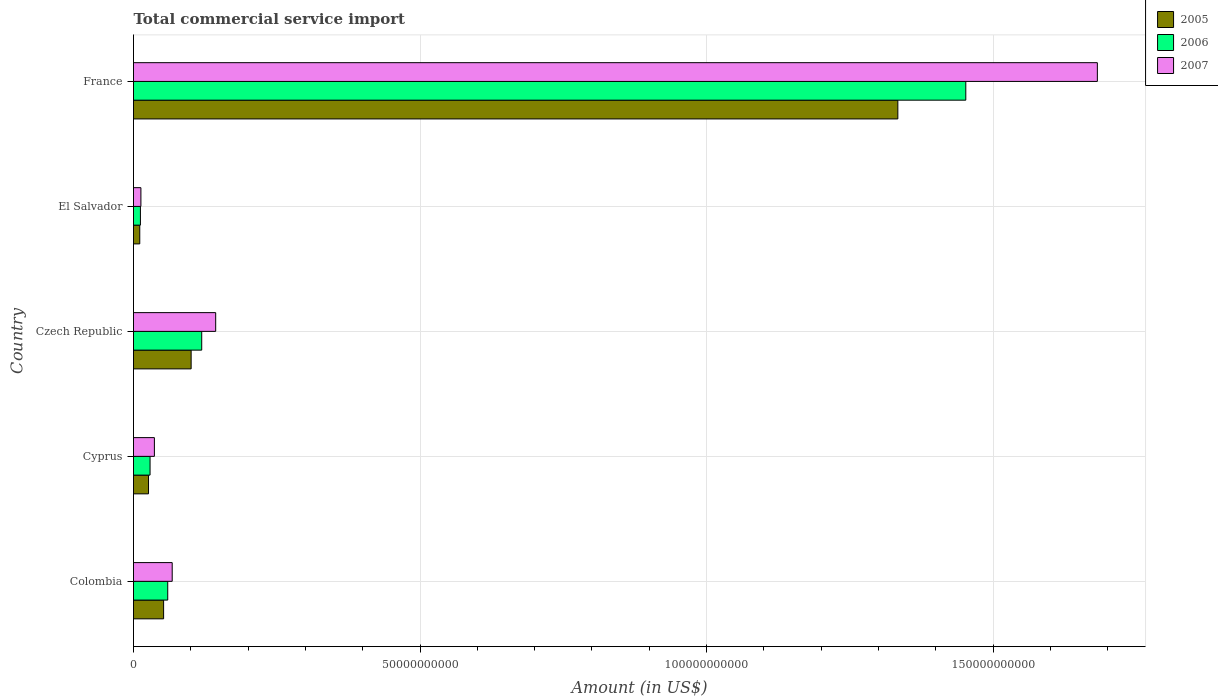How many groups of bars are there?
Keep it short and to the point. 5. Are the number of bars per tick equal to the number of legend labels?
Ensure brevity in your answer.  Yes. How many bars are there on the 2nd tick from the bottom?
Offer a terse response. 3. What is the total commercial service import in 2007 in Czech Republic?
Your answer should be compact. 1.43e+1. Across all countries, what is the maximum total commercial service import in 2005?
Keep it short and to the point. 1.33e+11. Across all countries, what is the minimum total commercial service import in 2005?
Give a very brief answer. 1.09e+09. In which country was the total commercial service import in 2007 maximum?
Your answer should be compact. France. In which country was the total commercial service import in 2006 minimum?
Ensure brevity in your answer.  El Salvador. What is the total total commercial service import in 2007 in the graph?
Your answer should be compact. 1.94e+11. What is the difference between the total commercial service import in 2005 in Colombia and that in Czech Republic?
Ensure brevity in your answer.  -4.80e+09. What is the difference between the total commercial service import in 2006 in Cyprus and the total commercial service import in 2005 in Colombia?
Ensure brevity in your answer.  -2.36e+09. What is the average total commercial service import in 2006 per country?
Keep it short and to the point. 3.34e+1. What is the difference between the total commercial service import in 2006 and total commercial service import in 2005 in Cyprus?
Your answer should be compact. 2.68e+08. In how many countries, is the total commercial service import in 2005 greater than 140000000000 US$?
Your response must be concise. 0. What is the ratio of the total commercial service import in 2007 in Colombia to that in Czech Republic?
Your response must be concise. 0.47. What is the difference between the highest and the second highest total commercial service import in 2005?
Keep it short and to the point. 1.23e+11. What is the difference between the highest and the lowest total commercial service import in 2006?
Provide a succinct answer. 1.44e+11. What does the 1st bar from the bottom in France represents?
Offer a very short reply. 2005. Are all the bars in the graph horizontal?
Your response must be concise. Yes. What is the difference between two consecutive major ticks on the X-axis?
Your answer should be compact. 5.00e+1. Are the values on the major ticks of X-axis written in scientific E-notation?
Give a very brief answer. No. Where does the legend appear in the graph?
Give a very brief answer. Top right. How many legend labels are there?
Provide a succinct answer. 3. How are the legend labels stacked?
Your answer should be very brief. Vertical. What is the title of the graph?
Your response must be concise. Total commercial service import. What is the label or title of the Y-axis?
Ensure brevity in your answer.  Country. What is the Amount (in US$) in 2005 in Colombia?
Offer a terse response. 5.25e+09. What is the Amount (in US$) of 2006 in Colombia?
Your response must be concise. 5.97e+09. What is the Amount (in US$) of 2007 in Colombia?
Ensure brevity in your answer.  6.75e+09. What is the Amount (in US$) of 2005 in Cyprus?
Keep it short and to the point. 2.62e+09. What is the Amount (in US$) in 2006 in Cyprus?
Give a very brief answer. 2.89e+09. What is the Amount (in US$) in 2007 in Cyprus?
Make the answer very short. 3.64e+09. What is the Amount (in US$) in 2005 in Czech Republic?
Offer a very short reply. 1.01e+1. What is the Amount (in US$) in 2006 in Czech Republic?
Keep it short and to the point. 1.19e+1. What is the Amount (in US$) of 2007 in Czech Republic?
Offer a terse response. 1.43e+1. What is the Amount (in US$) of 2005 in El Salvador?
Your answer should be compact. 1.09e+09. What is the Amount (in US$) in 2006 in El Salvador?
Offer a very short reply. 1.21e+09. What is the Amount (in US$) in 2007 in El Salvador?
Provide a short and direct response. 1.29e+09. What is the Amount (in US$) of 2005 in France?
Offer a very short reply. 1.33e+11. What is the Amount (in US$) in 2006 in France?
Give a very brief answer. 1.45e+11. What is the Amount (in US$) in 2007 in France?
Give a very brief answer. 1.68e+11. Across all countries, what is the maximum Amount (in US$) of 2005?
Ensure brevity in your answer.  1.33e+11. Across all countries, what is the maximum Amount (in US$) in 2006?
Your response must be concise. 1.45e+11. Across all countries, what is the maximum Amount (in US$) of 2007?
Ensure brevity in your answer.  1.68e+11. Across all countries, what is the minimum Amount (in US$) of 2005?
Offer a very short reply. 1.09e+09. Across all countries, what is the minimum Amount (in US$) of 2006?
Offer a terse response. 1.21e+09. Across all countries, what is the minimum Amount (in US$) in 2007?
Your answer should be very brief. 1.29e+09. What is the total Amount (in US$) of 2005 in the graph?
Make the answer very short. 1.52e+11. What is the total Amount (in US$) in 2006 in the graph?
Your answer should be very brief. 1.67e+11. What is the total Amount (in US$) of 2007 in the graph?
Make the answer very short. 1.94e+11. What is the difference between the Amount (in US$) in 2005 in Colombia and that in Cyprus?
Offer a terse response. 2.63e+09. What is the difference between the Amount (in US$) of 2006 in Colombia and that in Cyprus?
Your response must be concise. 3.09e+09. What is the difference between the Amount (in US$) of 2007 in Colombia and that in Cyprus?
Keep it short and to the point. 3.11e+09. What is the difference between the Amount (in US$) of 2005 in Colombia and that in Czech Republic?
Provide a short and direct response. -4.80e+09. What is the difference between the Amount (in US$) in 2006 in Colombia and that in Czech Republic?
Provide a short and direct response. -5.93e+09. What is the difference between the Amount (in US$) of 2007 in Colombia and that in Czech Republic?
Your answer should be compact. -7.59e+09. What is the difference between the Amount (in US$) in 2005 in Colombia and that in El Salvador?
Your response must be concise. 4.16e+09. What is the difference between the Amount (in US$) of 2006 in Colombia and that in El Salvador?
Provide a succinct answer. 4.77e+09. What is the difference between the Amount (in US$) in 2007 in Colombia and that in El Salvador?
Your answer should be very brief. 5.46e+09. What is the difference between the Amount (in US$) in 2005 in Colombia and that in France?
Provide a succinct answer. -1.28e+11. What is the difference between the Amount (in US$) in 2006 in Colombia and that in France?
Your answer should be compact. -1.39e+11. What is the difference between the Amount (in US$) of 2007 in Colombia and that in France?
Offer a terse response. -1.61e+11. What is the difference between the Amount (in US$) in 2005 in Cyprus and that in Czech Republic?
Your answer should be very brief. -7.44e+09. What is the difference between the Amount (in US$) of 2006 in Cyprus and that in Czech Republic?
Give a very brief answer. -9.01e+09. What is the difference between the Amount (in US$) in 2007 in Cyprus and that in Czech Republic?
Offer a very short reply. -1.07e+1. What is the difference between the Amount (in US$) in 2005 in Cyprus and that in El Salvador?
Make the answer very short. 1.53e+09. What is the difference between the Amount (in US$) of 2006 in Cyprus and that in El Salvador?
Your answer should be compact. 1.68e+09. What is the difference between the Amount (in US$) in 2007 in Cyprus and that in El Salvador?
Keep it short and to the point. 2.35e+09. What is the difference between the Amount (in US$) in 2005 in Cyprus and that in France?
Offer a terse response. -1.31e+11. What is the difference between the Amount (in US$) of 2006 in Cyprus and that in France?
Ensure brevity in your answer.  -1.42e+11. What is the difference between the Amount (in US$) of 2007 in Cyprus and that in France?
Keep it short and to the point. -1.65e+11. What is the difference between the Amount (in US$) in 2005 in Czech Republic and that in El Salvador?
Keep it short and to the point. 8.96e+09. What is the difference between the Amount (in US$) in 2006 in Czech Republic and that in El Salvador?
Your response must be concise. 1.07e+1. What is the difference between the Amount (in US$) of 2007 in Czech Republic and that in El Salvador?
Keep it short and to the point. 1.31e+1. What is the difference between the Amount (in US$) in 2005 in Czech Republic and that in France?
Ensure brevity in your answer.  -1.23e+11. What is the difference between the Amount (in US$) in 2006 in Czech Republic and that in France?
Provide a short and direct response. -1.33e+11. What is the difference between the Amount (in US$) in 2007 in Czech Republic and that in France?
Your response must be concise. -1.54e+11. What is the difference between the Amount (in US$) in 2005 in El Salvador and that in France?
Provide a succinct answer. -1.32e+11. What is the difference between the Amount (in US$) in 2006 in El Salvador and that in France?
Keep it short and to the point. -1.44e+11. What is the difference between the Amount (in US$) of 2007 in El Salvador and that in France?
Offer a very short reply. -1.67e+11. What is the difference between the Amount (in US$) in 2005 in Colombia and the Amount (in US$) in 2006 in Cyprus?
Provide a succinct answer. 2.36e+09. What is the difference between the Amount (in US$) of 2005 in Colombia and the Amount (in US$) of 2007 in Cyprus?
Offer a very short reply. 1.61e+09. What is the difference between the Amount (in US$) in 2006 in Colombia and the Amount (in US$) in 2007 in Cyprus?
Keep it short and to the point. 2.33e+09. What is the difference between the Amount (in US$) in 2005 in Colombia and the Amount (in US$) in 2006 in Czech Republic?
Your answer should be compact. -6.65e+09. What is the difference between the Amount (in US$) of 2005 in Colombia and the Amount (in US$) of 2007 in Czech Republic?
Give a very brief answer. -9.09e+09. What is the difference between the Amount (in US$) of 2006 in Colombia and the Amount (in US$) of 2007 in Czech Republic?
Offer a terse response. -8.37e+09. What is the difference between the Amount (in US$) in 2005 in Colombia and the Amount (in US$) in 2006 in El Salvador?
Provide a short and direct response. 4.05e+09. What is the difference between the Amount (in US$) in 2005 in Colombia and the Amount (in US$) in 2007 in El Salvador?
Your answer should be compact. 3.96e+09. What is the difference between the Amount (in US$) in 2006 in Colombia and the Amount (in US$) in 2007 in El Salvador?
Your response must be concise. 4.68e+09. What is the difference between the Amount (in US$) of 2005 in Colombia and the Amount (in US$) of 2006 in France?
Keep it short and to the point. -1.40e+11. What is the difference between the Amount (in US$) in 2005 in Colombia and the Amount (in US$) in 2007 in France?
Offer a terse response. -1.63e+11. What is the difference between the Amount (in US$) in 2006 in Colombia and the Amount (in US$) in 2007 in France?
Offer a terse response. -1.62e+11. What is the difference between the Amount (in US$) of 2005 in Cyprus and the Amount (in US$) of 2006 in Czech Republic?
Provide a short and direct response. -9.28e+09. What is the difference between the Amount (in US$) in 2005 in Cyprus and the Amount (in US$) in 2007 in Czech Republic?
Your answer should be very brief. -1.17e+1. What is the difference between the Amount (in US$) of 2006 in Cyprus and the Amount (in US$) of 2007 in Czech Republic?
Your response must be concise. -1.15e+1. What is the difference between the Amount (in US$) of 2005 in Cyprus and the Amount (in US$) of 2006 in El Salvador?
Offer a very short reply. 1.41e+09. What is the difference between the Amount (in US$) of 2005 in Cyprus and the Amount (in US$) of 2007 in El Salvador?
Your answer should be very brief. 1.33e+09. What is the difference between the Amount (in US$) of 2006 in Cyprus and the Amount (in US$) of 2007 in El Salvador?
Provide a short and direct response. 1.60e+09. What is the difference between the Amount (in US$) of 2005 in Cyprus and the Amount (in US$) of 2006 in France?
Provide a succinct answer. -1.43e+11. What is the difference between the Amount (in US$) in 2005 in Cyprus and the Amount (in US$) in 2007 in France?
Give a very brief answer. -1.66e+11. What is the difference between the Amount (in US$) in 2006 in Cyprus and the Amount (in US$) in 2007 in France?
Offer a very short reply. -1.65e+11. What is the difference between the Amount (in US$) in 2005 in Czech Republic and the Amount (in US$) in 2006 in El Salvador?
Provide a short and direct response. 8.85e+09. What is the difference between the Amount (in US$) in 2005 in Czech Republic and the Amount (in US$) in 2007 in El Salvador?
Your answer should be compact. 8.77e+09. What is the difference between the Amount (in US$) of 2006 in Czech Republic and the Amount (in US$) of 2007 in El Salvador?
Your response must be concise. 1.06e+1. What is the difference between the Amount (in US$) in 2005 in Czech Republic and the Amount (in US$) in 2006 in France?
Your answer should be very brief. -1.35e+11. What is the difference between the Amount (in US$) of 2005 in Czech Republic and the Amount (in US$) of 2007 in France?
Provide a succinct answer. -1.58e+11. What is the difference between the Amount (in US$) of 2006 in Czech Republic and the Amount (in US$) of 2007 in France?
Keep it short and to the point. -1.56e+11. What is the difference between the Amount (in US$) of 2005 in El Salvador and the Amount (in US$) of 2006 in France?
Provide a short and direct response. -1.44e+11. What is the difference between the Amount (in US$) in 2005 in El Salvador and the Amount (in US$) in 2007 in France?
Keep it short and to the point. -1.67e+11. What is the difference between the Amount (in US$) of 2006 in El Salvador and the Amount (in US$) of 2007 in France?
Give a very brief answer. -1.67e+11. What is the average Amount (in US$) in 2005 per country?
Keep it short and to the point. 3.05e+1. What is the average Amount (in US$) in 2006 per country?
Offer a very short reply. 3.34e+1. What is the average Amount (in US$) of 2007 per country?
Provide a succinct answer. 3.88e+1. What is the difference between the Amount (in US$) of 2005 and Amount (in US$) of 2006 in Colombia?
Your answer should be very brief. -7.20e+08. What is the difference between the Amount (in US$) in 2005 and Amount (in US$) in 2007 in Colombia?
Keep it short and to the point. -1.50e+09. What is the difference between the Amount (in US$) in 2006 and Amount (in US$) in 2007 in Colombia?
Offer a very short reply. -7.78e+08. What is the difference between the Amount (in US$) of 2005 and Amount (in US$) of 2006 in Cyprus?
Give a very brief answer. -2.68e+08. What is the difference between the Amount (in US$) in 2005 and Amount (in US$) in 2007 in Cyprus?
Your answer should be compact. -1.02e+09. What is the difference between the Amount (in US$) in 2006 and Amount (in US$) in 2007 in Cyprus?
Your response must be concise. -7.56e+08. What is the difference between the Amount (in US$) in 2005 and Amount (in US$) in 2006 in Czech Republic?
Give a very brief answer. -1.84e+09. What is the difference between the Amount (in US$) in 2005 and Amount (in US$) in 2007 in Czech Republic?
Your answer should be compact. -4.28e+09. What is the difference between the Amount (in US$) of 2006 and Amount (in US$) of 2007 in Czech Republic?
Offer a very short reply. -2.44e+09. What is the difference between the Amount (in US$) of 2005 and Amount (in US$) of 2006 in El Salvador?
Offer a terse response. -1.13e+08. What is the difference between the Amount (in US$) of 2005 and Amount (in US$) of 2007 in El Salvador?
Give a very brief answer. -1.97e+08. What is the difference between the Amount (in US$) in 2006 and Amount (in US$) in 2007 in El Salvador?
Keep it short and to the point. -8.46e+07. What is the difference between the Amount (in US$) in 2005 and Amount (in US$) in 2006 in France?
Provide a short and direct response. -1.19e+1. What is the difference between the Amount (in US$) of 2005 and Amount (in US$) of 2007 in France?
Provide a short and direct response. -3.48e+1. What is the difference between the Amount (in US$) of 2006 and Amount (in US$) of 2007 in France?
Provide a succinct answer. -2.30e+1. What is the ratio of the Amount (in US$) of 2005 in Colombia to that in Cyprus?
Offer a terse response. 2.01. What is the ratio of the Amount (in US$) in 2006 in Colombia to that in Cyprus?
Offer a very short reply. 2.07. What is the ratio of the Amount (in US$) in 2007 in Colombia to that in Cyprus?
Provide a succinct answer. 1.85. What is the ratio of the Amount (in US$) in 2005 in Colombia to that in Czech Republic?
Give a very brief answer. 0.52. What is the ratio of the Amount (in US$) in 2006 in Colombia to that in Czech Republic?
Your answer should be very brief. 0.5. What is the ratio of the Amount (in US$) in 2007 in Colombia to that in Czech Republic?
Your answer should be compact. 0.47. What is the ratio of the Amount (in US$) of 2005 in Colombia to that in El Salvador?
Make the answer very short. 4.81. What is the ratio of the Amount (in US$) in 2006 in Colombia to that in El Salvador?
Your answer should be compact. 4.96. What is the ratio of the Amount (in US$) in 2007 in Colombia to that in El Salvador?
Your response must be concise. 5.23. What is the ratio of the Amount (in US$) in 2005 in Colombia to that in France?
Give a very brief answer. 0.04. What is the ratio of the Amount (in US$) of 2006 in Colombia to that in France?
Your answer should be very brief. 0.04. What is the ratio of the Amount (in US$) in 2007 in Colombia to that in France?
Offer a very short reply. 0.04. What is the ratio of the Amount (in US$) of 2005 in Cyprus to that in Czech Republic?
Ensure brevity in your answer.  0.26. What is the ratio of the Amount (in US$) of 2006 in Cyprus to that in Czech Republic?
Your answer should be very brief. 0.24. What is the ratio of the Amount (in US$) of 2007 in Cyprus to that in Czech Republic?
Offer a terse response. 0.25. What is the ratio of the Amount (in US$) in 2005 in Cyprus to that in El Salvador?
Offer a very short reply. 2.4. What is the ratio of the Amount (in US$) of 2006 in Cyprus to that in El Salvador?
Your response must be concise. 2.4. What is the ratio of the Amount (in US$) in 2007 in Cyprus to that in El Salvador?
Provide a short and direct response. 2.83. What is the ratio of the Amount (in US$) in 2005 in Cyprus to that in France?
Offer a very short reply. 0.02. What is the ratio of the Amount (in US$) of 2006 in Cyprus to that in France?
Your answer should be very brief. 0.02. What is the ratio of the Amount (in US$) in 2007 in Cyprus to that in France?
Offer a very short reply. 0.02. What is the ratio of the Amount (in US$) in 2005 in Czech Republic to that in El Salvador?
Offer a terse response. 9.2. What is the ratio of the Amount (in US$) in 2006 in Czech Republic to that in El Salvador?
Your answer should be compact. 9.87. What is the ratio of the Amount (in US$) of 2007 in Czech Republic to that in El Salvador?
Your answer should be very brief. 11.12. What is the ratio of the Amount (in US$) of 2005 in Czech Republic to that in France?
Your answer should be compact. 0.08. What is the ratio of the Amount (in US$) of 2006 in Czech Republic to that in France?
Keep it short and to the point. 0.08. What is the ratio of the Amount (in US$) in 2007 in Czech Republic to that in France?
Make the answer very short. 0.09. What is the ratio of the Amount (in US$) of 2005 in El Salvador to that in France?
Your answer should be compact. 0.01. What is the ratio of the Amount (in US$) of 2006 in El Salvador to that in France?
Provide a short and direct response. 0.01. What is the ratio of the Amount (in US$) of 2007 in El Salvador to that in France?
Give a very brief answer. 0.01. What is the difference between the highest and the second highest Amount (in US$) in 2005?
Provide a succinct answer. 1.23e+11. What is the difference between the highest and the second highest Amount (in US$) of 2006?
Your response must be concise. 1.33e+11. What is the difference between the highest and the second highest Amount (in US$) of 2007?
Offer a terse response. 1.54e+11. What is the difference between the highest and the lowest Amount (in US$) in 2005?
Make the answer very short. 1.32e+11. What is the difference between the highest and the lowest Amount (in US$) of 2006?
Offer a terse response. 1.44e+11. What is the difference between the highest and the lowest Amount (in US$) of 2007?
Give a very brief answer. 1.67e+11. 